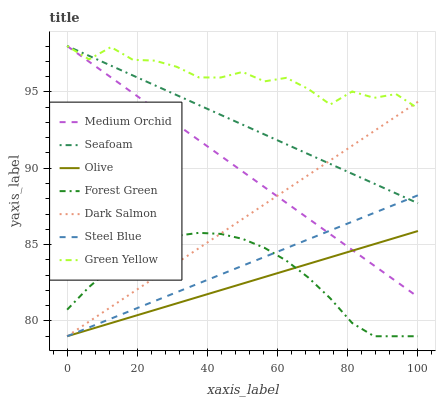Does Olive have the minimum area under the curve?
Answer yes or no. Yes. Does Green Yellow have the maximum area under the curve?
Answer yes or no. Yes. Does Seafoam have the minimum area under the curve?
Answer yes or no. No. Does Seafoam have the maximum area under the curve?
Answer yes or no. No. Is Medium Orchid the smoothest?
Answer yes or no. Yes. Is Green Yellow the roughest?
Answer yes or no. Yes. Is Seafoam the smoothest?
Answer yes or no. No. Is Seafoam the roughest?
Answer yes or no. No. Does Steel Blue have the lowest value?
Answer yes or no. Yes. Does Seafoam have the lowest value?
Answer yes or no. No. Does Green Yellow have the highest value?
Answer yes or no. Yes. Does Steel Blue have the highest value?
Answer yes or no. No. Is Olive less than Green Yellow?
Answer yes or no. Yes. Is Seafoam greater than Forest Green?
Answer yes or no. Yes. Does Medium Orchid intersect Steel Blue?
Answer yes or no. Yes. Is Medium Orchid less than Steel Blue?
Answer yes or no. No. Is Medium Orchid greater than Steel Blue?
Answer yes or no. No. Does Olive intersect Green Yellow?
Answer yes or no. No. 